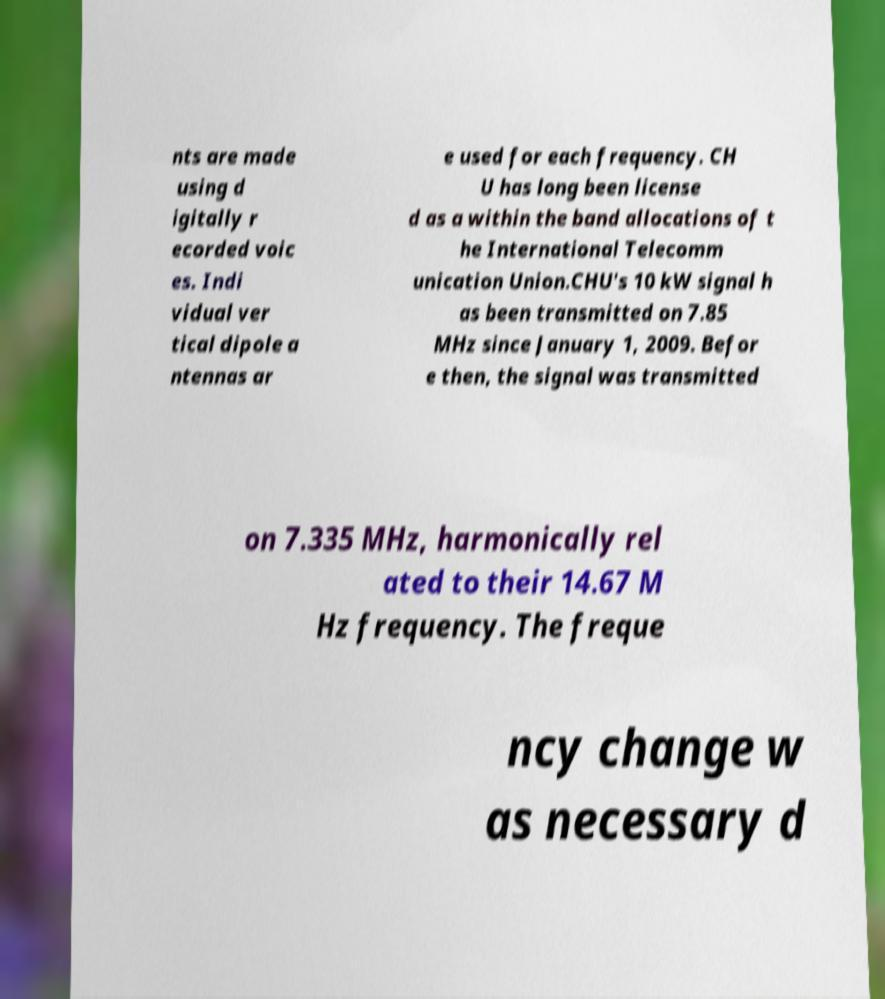Could you extract and type out the text from this image? nts are made using d igitally r ecorded voic es. Indi vidual ver tical dipole a ntennas ar e used for each frequency. CH U has long been license d as a within the band allocations of t he International Telecomm unication Union.CHU's 10 kW signal h as been transmitted on 7.85 MHz since January 1, 2009. Befor e then, the signal was transmitted on 7.335 MHz, harmonically rel ated to their 14.67 M Hz frequency. The freque ncy change w as necessary d 